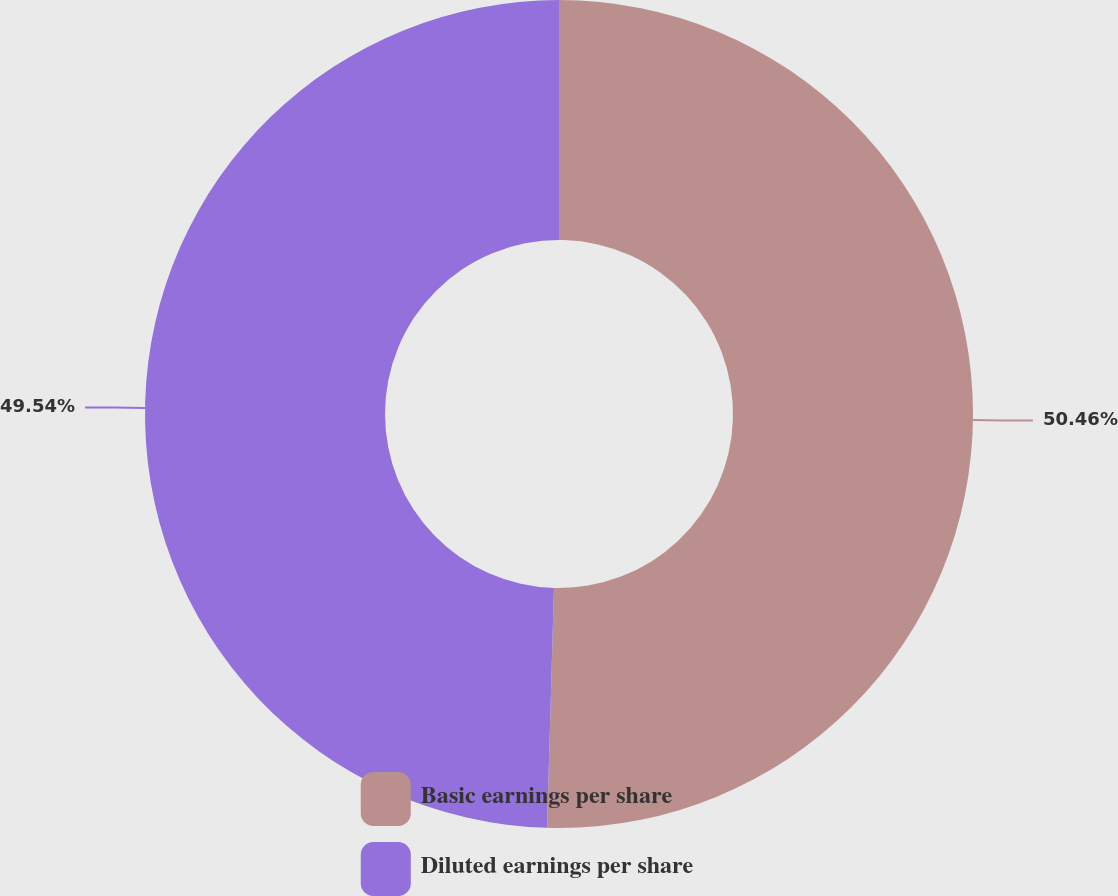<chart> <loc_0><loc_0><loc_500><loc_500><pie_chart><fcel>Basic earnings per share<fcel>Diluted earnings per share<nl><fcel>50.46%<fcel>49.54%<nl></chart> 